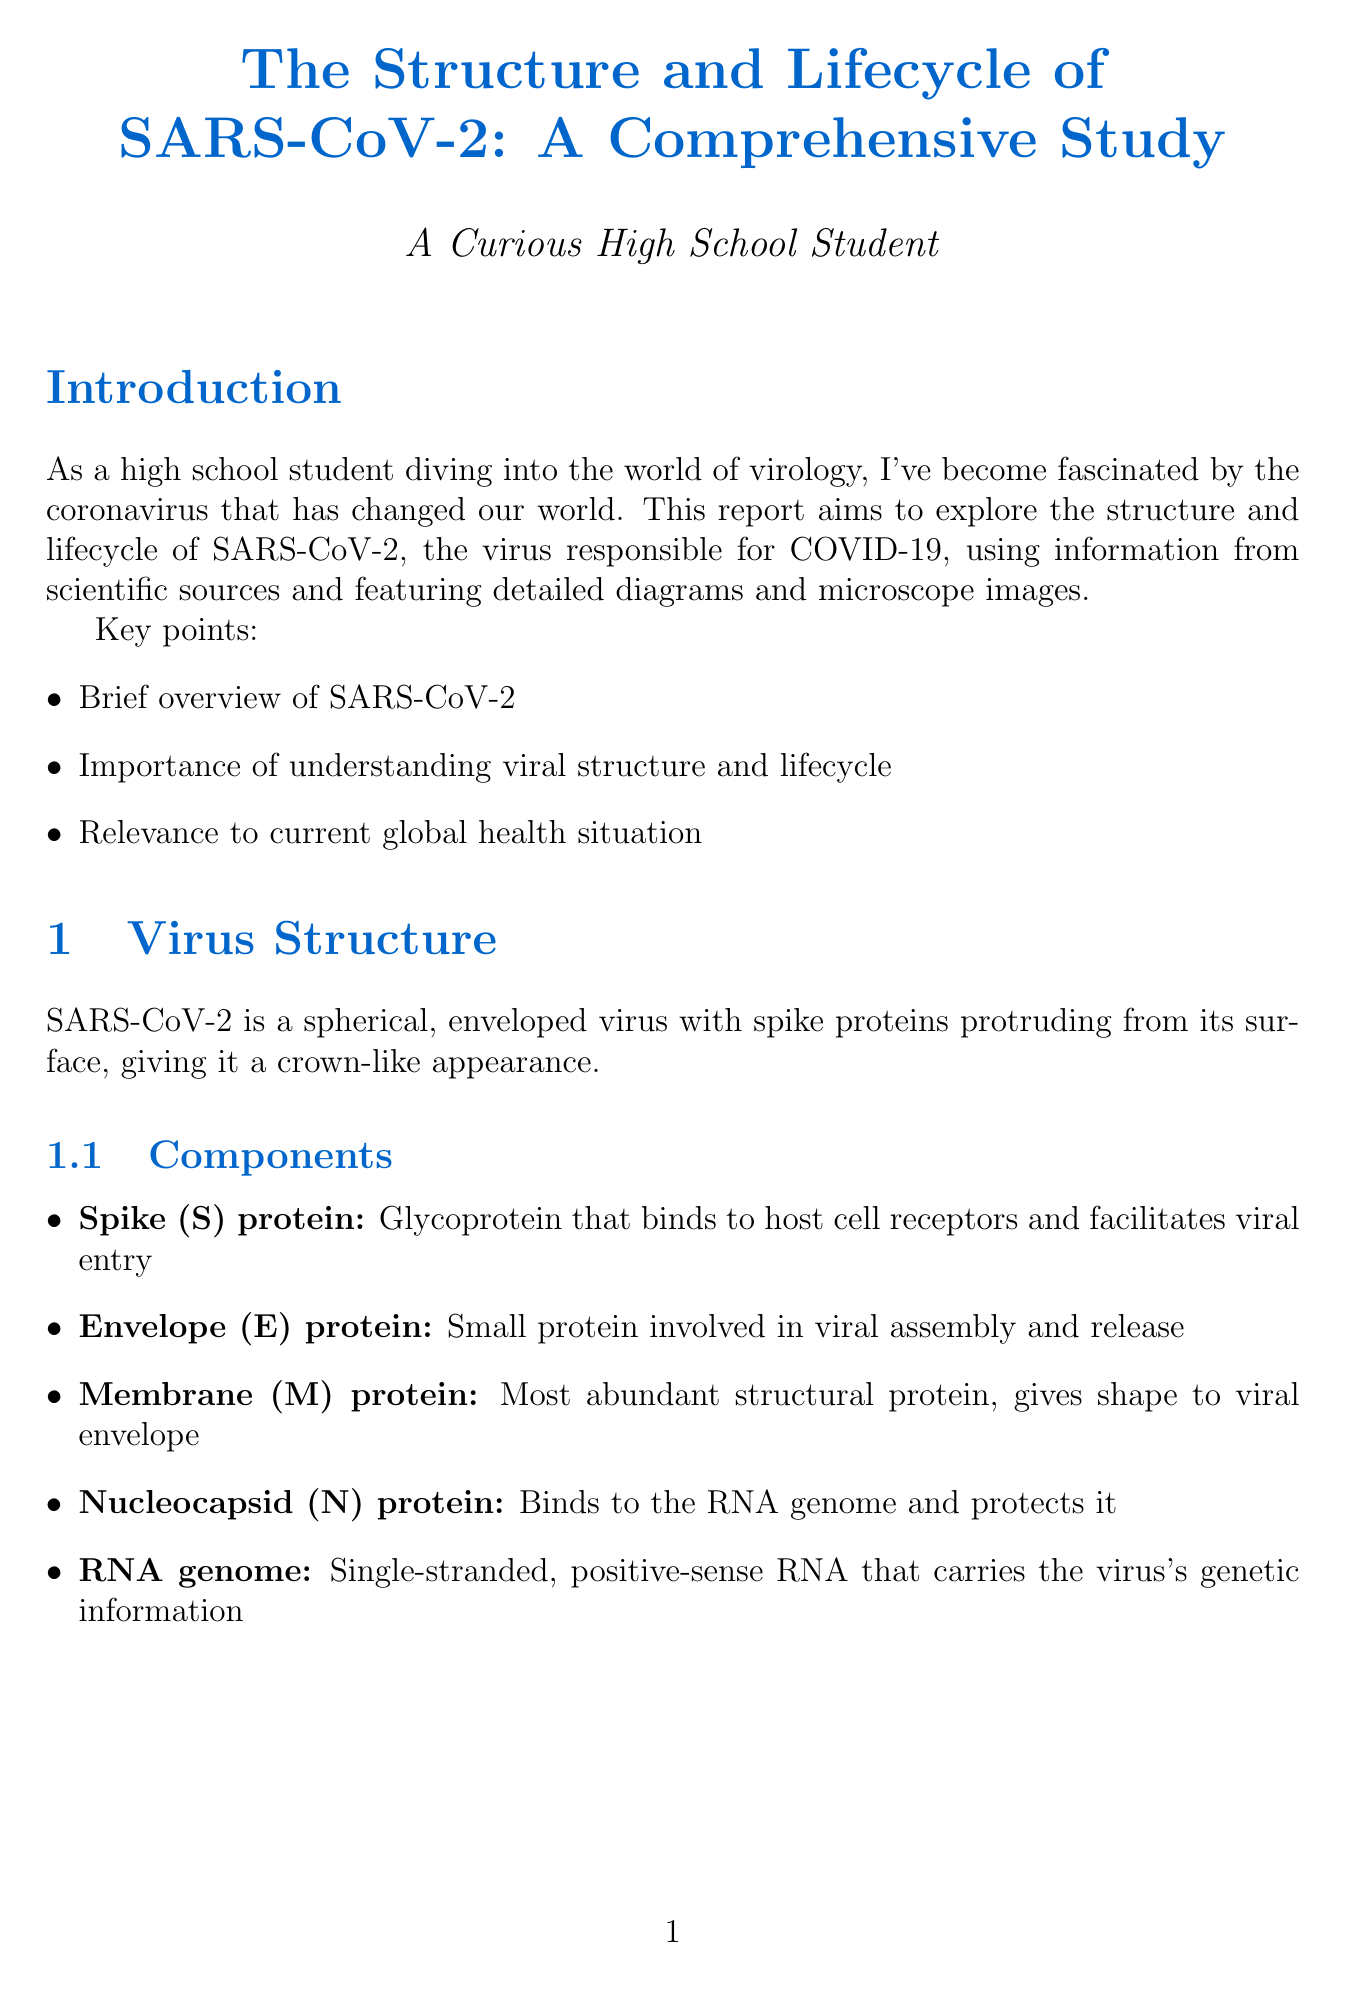What is the title of the report? The title is mentioned at the beginning of the document as "The Structure and Lifecycle of SARS-CoV-2: A Comprehensive Study."
Answer: The Structure and Lifecycle of SARS-CoV-2: A Comprehensive Study What are the components of SARS-CoV-2? The document lists five components of SARS-CoV-2, which include Spike (S) protein, Envelope (E) protein, Membrane (M) protein, Nucleocapsid (N) protein, and RNA genome.
Answer: Spike (S) protein, Envelope (E) protein, Membrane (M) protein, Nucleocapsid (N) protein, RNA genome What is the receptor for SARS-CoV-2? The document states that SARS-CoV-2 uses the ACE2 receptor.
Answer: ACE2 How many stages are there in the viral lifecycle? The number of stages in the viral lifecycle is explicitly stated in the document under the Viral Lifecycle section.
Answer: Six What is a key direction for future research? The document lists ongoing research into viral mutations as a future direction.
Answer: Ongoing research into viral mutations Describe a notable feature of SARS-CoV-2 compared to other coronaviruses. The comparison indicates that SARS-CoV-2 has unique features that contribute to its high infectivity and global spread.
Answer: High infectivity What type of images are included in the report? The report mentions including microscope images, specifically transmission electron microscope images and colorized scanning electron micrographs.
Answer: Microscope images What is the genome size of SARS-CoV-2? The document specifies the genome size of SARS-CoV-2 as approximately 30 kb.
Answer: Approximately 30 kb What does the spike protein do? The document describes the spike protein's function as binding to host cell receptors and facilitating viral entry.
Answer: Binds to host cell receptors and facilitates viral entry 